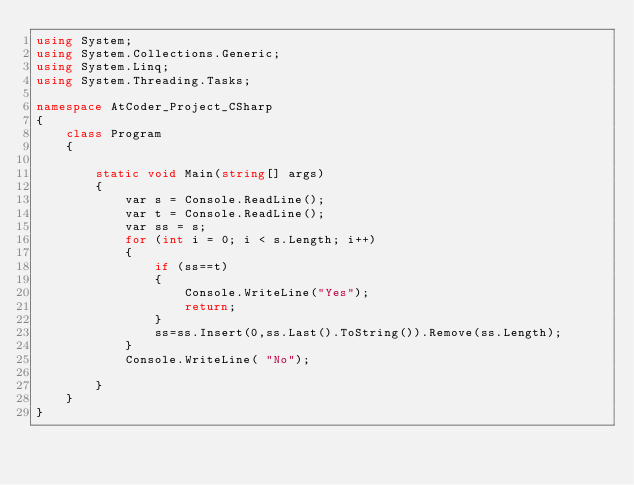Convert code to text. <code><loc_0><loc_0><loc_500><loc_500><_C#_>using System;
using System.Collections.Generic;
using System.Linq;
using System.Threading.Tasks;

namespace AtCoder_Project_CSharp
{
    class Program
    {

        static void Main(string[] args)
        {
            var s = Console.ReadLine();
            var t = Console.ReadLine();
            var ss = s;
            for (int i = 0; i < s.Length; i++)
            {
                if (ss==t)
                {
                    Console.WriteLine("Yes");
                    return;
                }
                ss=ss.Insert(0,ss.Last().ToString()).Remove(ss.Length);
            }
            Console.WriteLine( "No");

        }
    }
}
</code> 